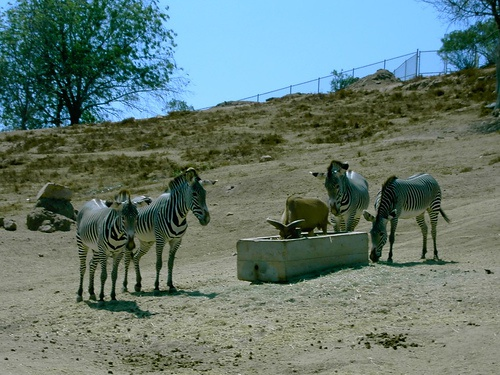Describe the objects in this image and their specific colors. I can see zebra in lightblue, black, gray, darkgray, and darkgreen tones, zebra in lightblue, black, gray, and darkgreen tones, zebra in lightblue, black, gray, darkgreen, and teal tones, and zebra in lightblue, black, gray, and darkgreen tones in this image. 